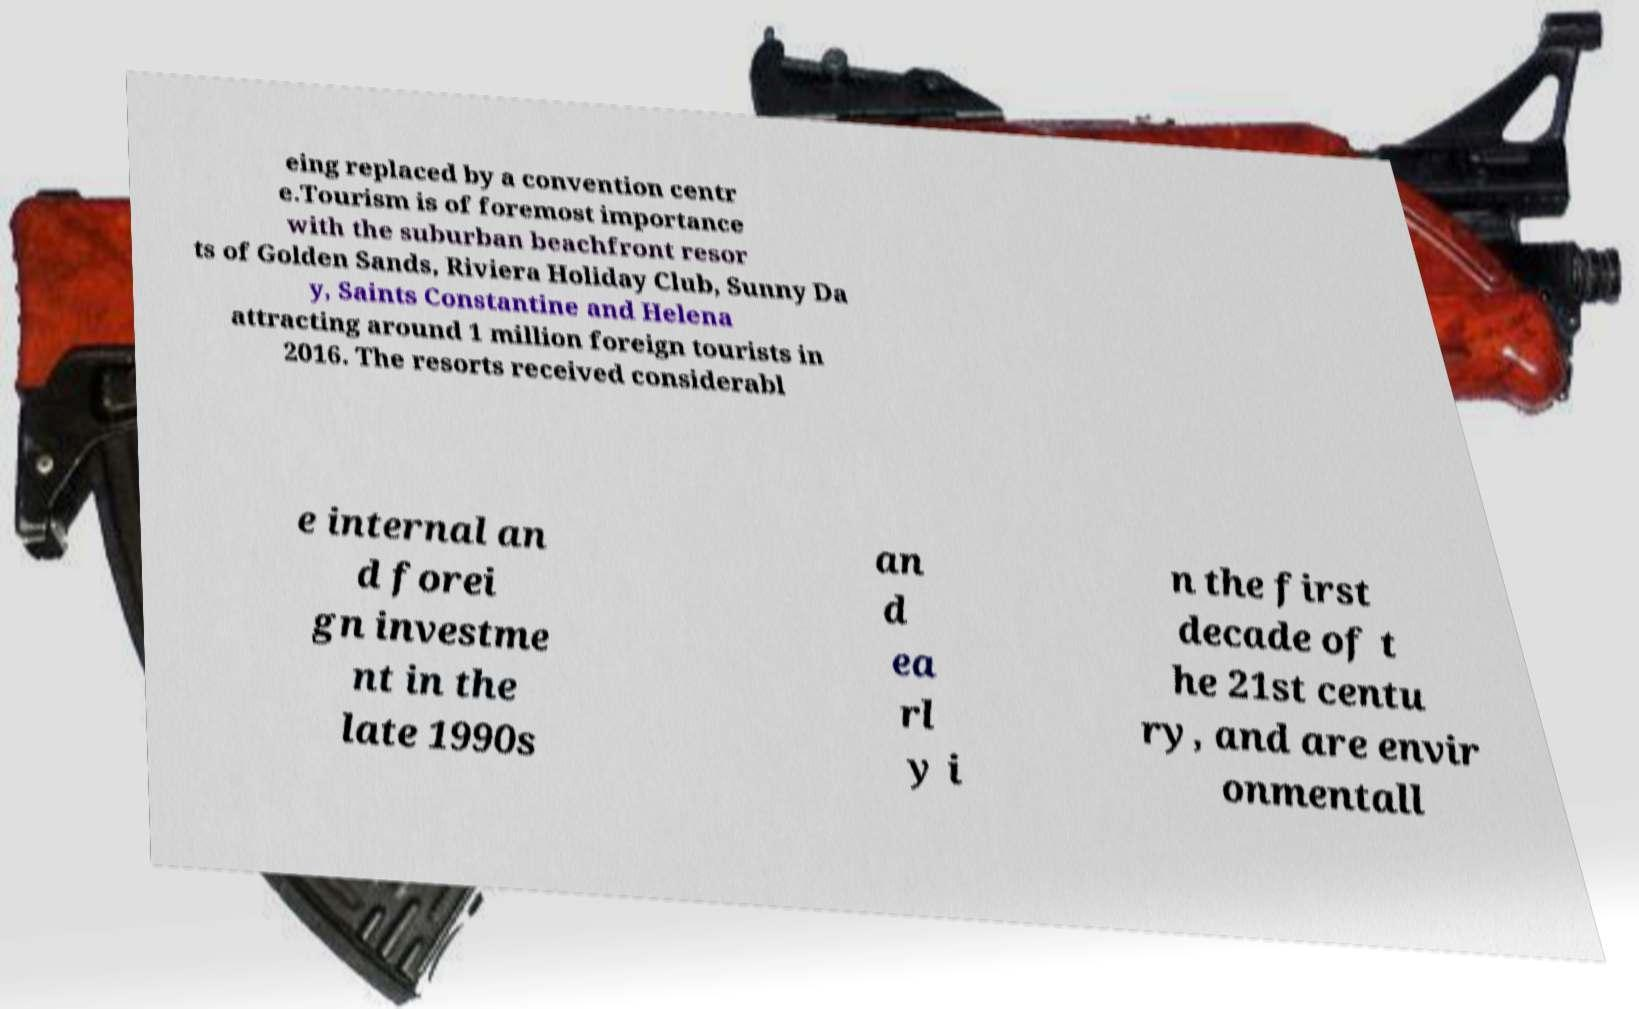Could you extract and type out the text from this image? eing replaced by a convention centr e.Tourism is of foremost importance with the suburban beachfront resor ts of Golden Sands, Riviera Holiday Club, Sunny Da y, Saints Constantine and Helena attracting around 1 million foreign tourists in 2016. The resorts received considerabl e internal an d forei gn investme nt in the late 1990s an d ea rl y i n the first decade of t he 21st centu ry, and are envir onmentall 